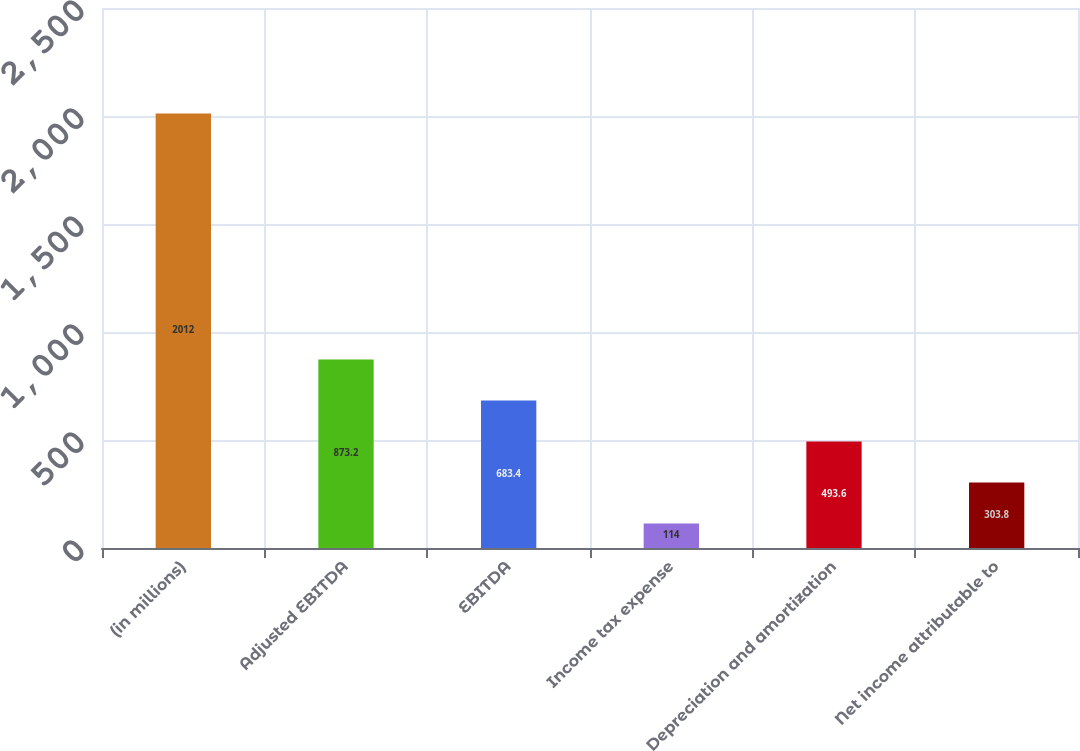<chart> <loc_0><loc_0><loc_500><loc_500><bar_chart><fcel>(in millions)<fcel>Adjusted EBITDA<fcel>EBITDA<fcel>Income tax expense<fcel>Depreciation and amortization<fcel>Net income attributable to<nl><fcel>2012<fcel>873.2<fcel>683.4<fcel>114<fcel>493.6<fcel>303.8<nl></chart> 